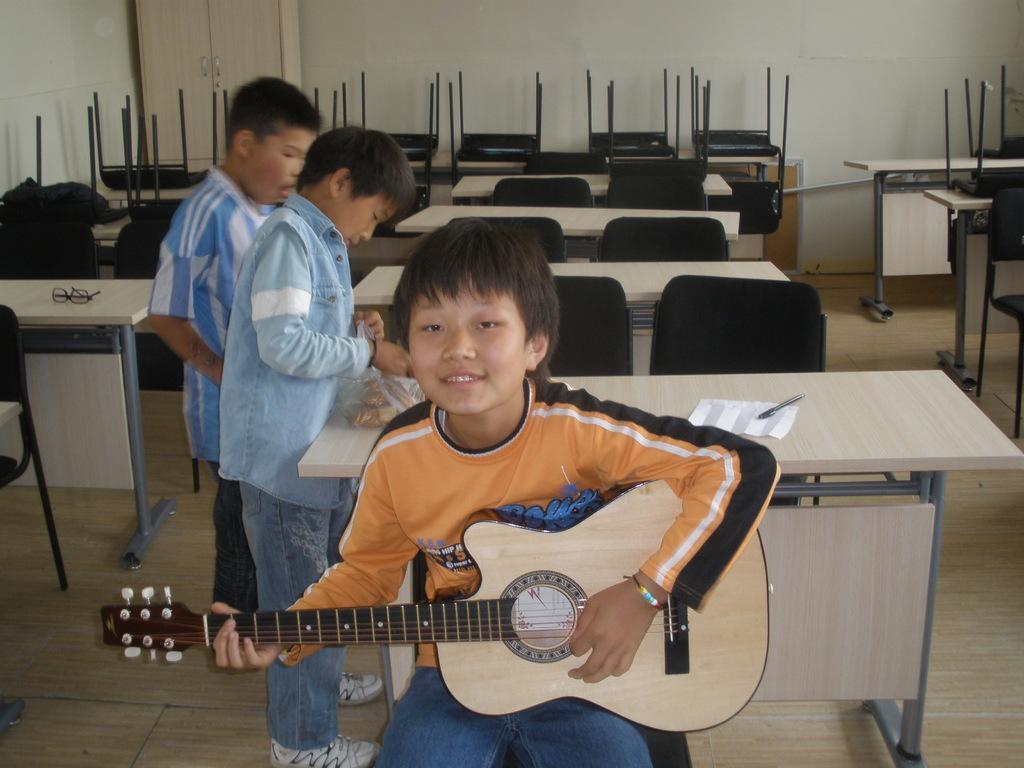In one or two sentences, can you explain what this image depicts? This image consists of tables, chairs and three children. One child who is in the middle is playing guitar and two people are standing on the left side. On table there is a pen and paper. 